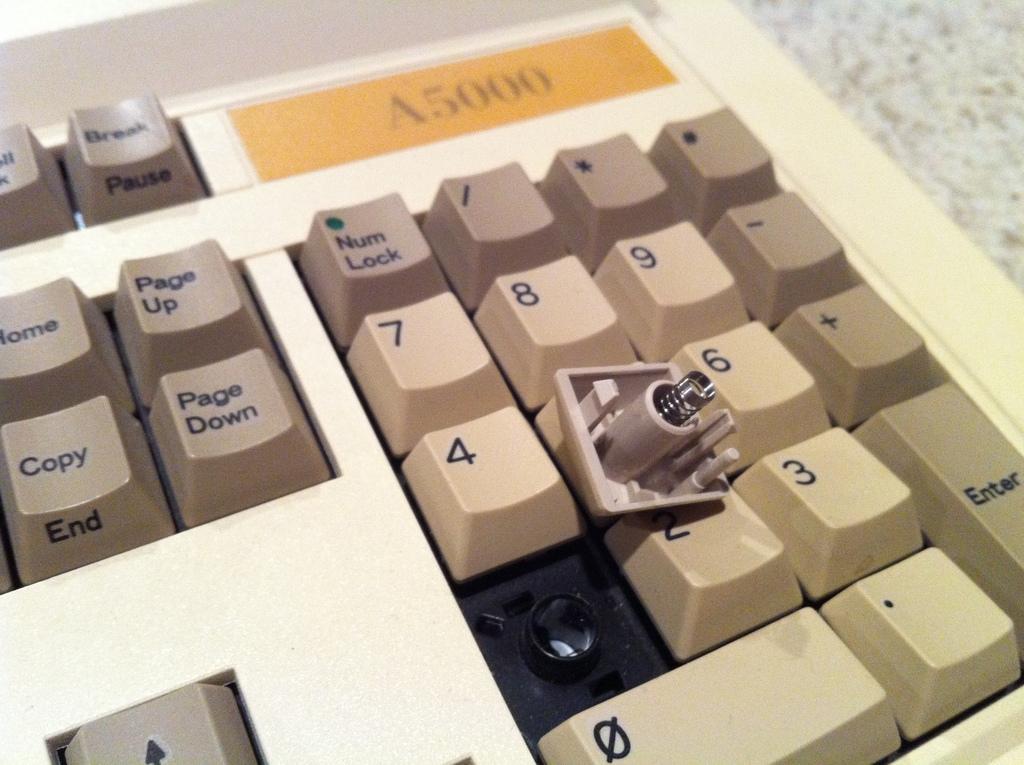What is the key button missing??
Offer a terse response. 1. 